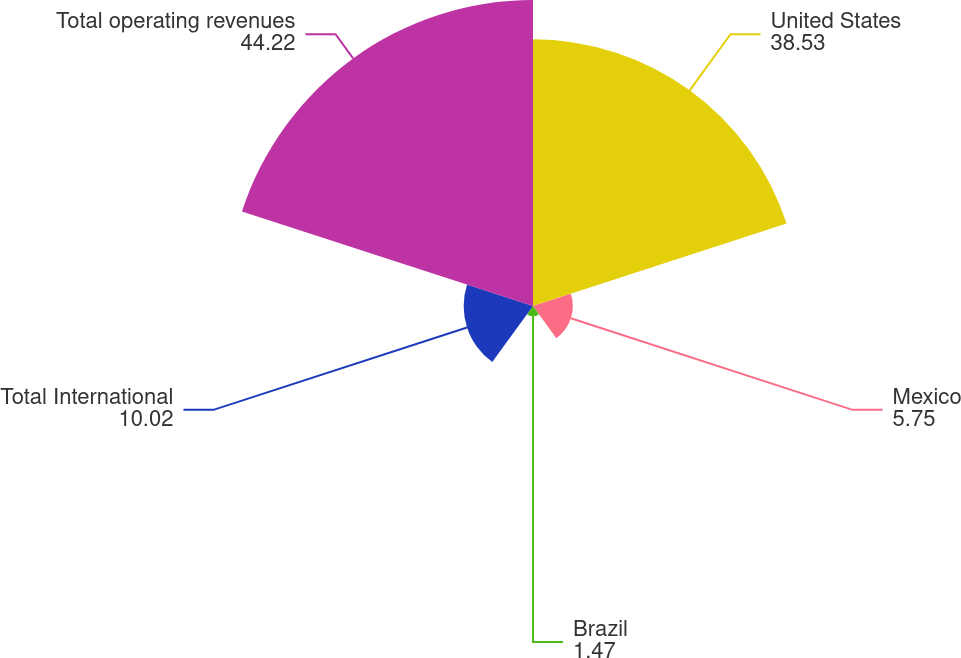<chart> <loc_0><loc_0><loc_500><loc_500><pie_chart><fcel>United States<fcel>Mexico<fcel>Brazil<fcel>Total International<fcel>Total operating revenues<nl><fcel>38.53%<fcel>5.75%<fcel>1.47%<fcel>10.02%<fcel>44.22%<nl></chart> 